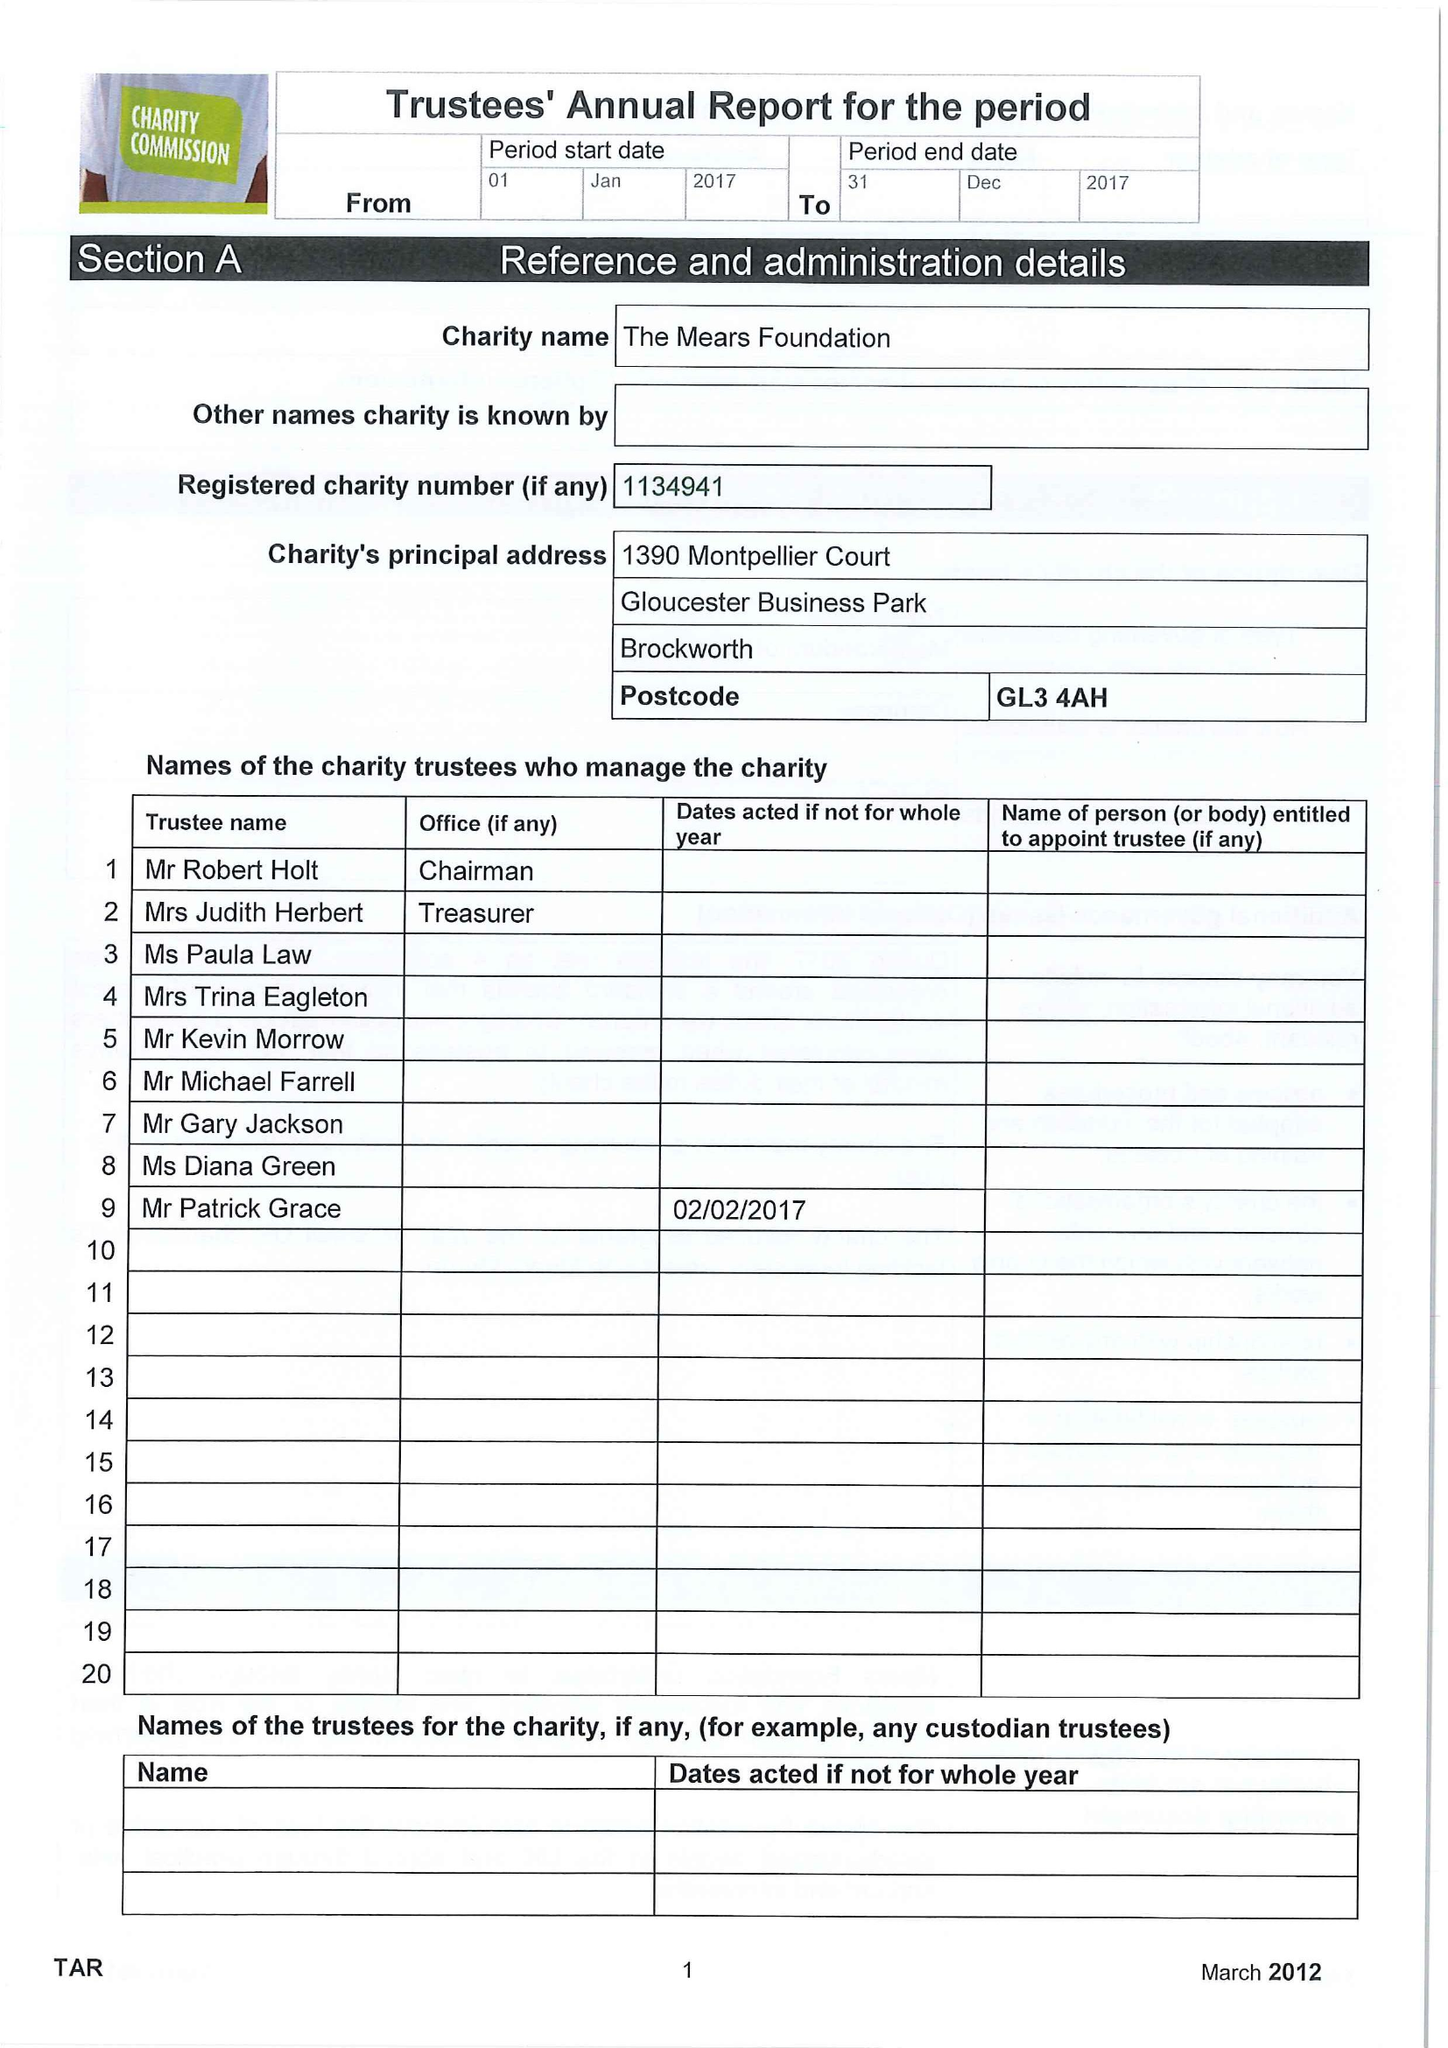What is the value for the address__postcode?
Answer the question using a single word or phrase. GL3 4AH 